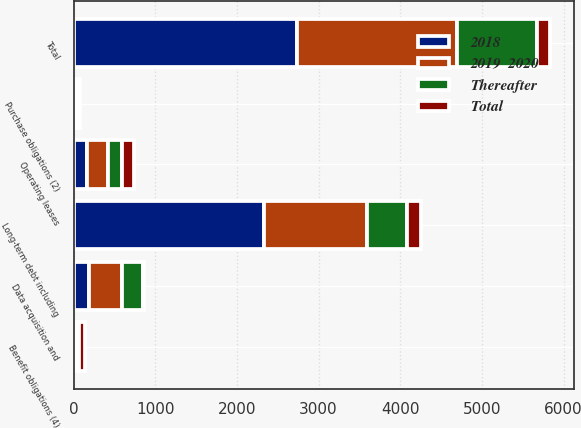Convert chart. <chart><loc_0><loc_0><loc_500><loc_500><stacked_bar_chart><ecel><fcel>Long-term debt including<fcel>Operating leases<fcel>Data acquisition and<fcel>Purchase obligations (2)<fcel>Benefit obligations (4)<fcel>Total<nl><fcel>Thereafter<fcel>496<fcel>169<fcel>254<fcel>28<fcel>22<fcel>978<nl><fcel>2019  2020<fcel>1251<fcel>250<fcel>397<fcel>29<fcel>23<fcel>1950<nl><fcel>2018<fcel>2336<fcel>169<fcel>194<fcel>17<fcel>24<fcel>2740<nl><fcel>Total<fcel>169<fcel>157<fcel>13<fcel>3<fcel>74<fcel>169<nl></chart> 